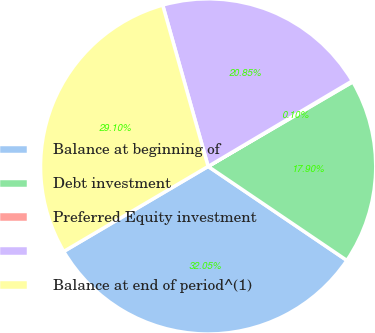<chart> <loc_0><loc_0><loc_500><loc_500><pie_chart><fcel>Balance at beginning of<fcel>Debt investment<fcel>Preferred Equity investment<fcel>Unnamed: 3<fcel>Balance at end of period^(1)<nl><fcel>32.05%<fcel>17.9%<fcel>0.1%<fcel>20.85%<fcel>29.1%<nl></chart> 